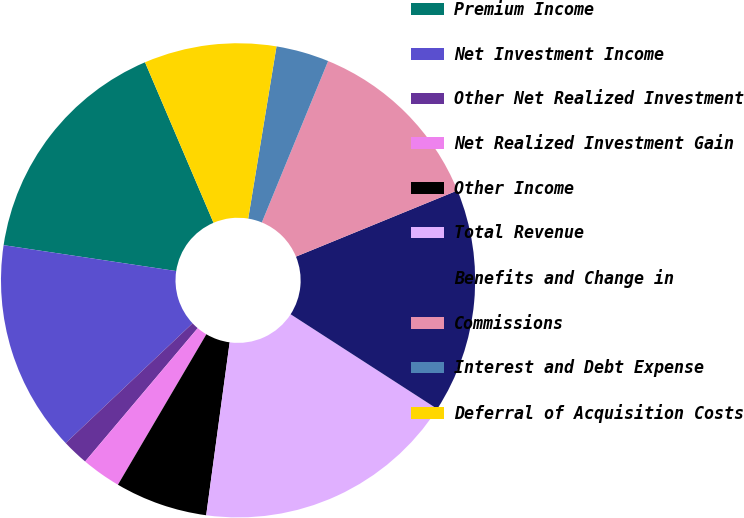Convert chart. <chart><loc_0><loc_0><loc_500><loc_500><pie_chart><fcel>Premium Income<fcel>Net Investment Income<fcel>Other Net Realized Investment<fcel>Net Realized Investment Gain<fcel>Other Income<fcel>Total Revenue<fcel>Benefits and Change in<fcel>Commissions<fcel>Interest and Debt Expense<fcel>Deferral of Acquisition Costs<nl><fcel>16.21%<fcel>14.41%<fcel>1.8%<fcel>2.7%<fcel>6.31%<fcel>18.02%<fcel>15.31%<fcel>12.61%<fcel>3.61%<fcel>9.01%<nl></chart> 